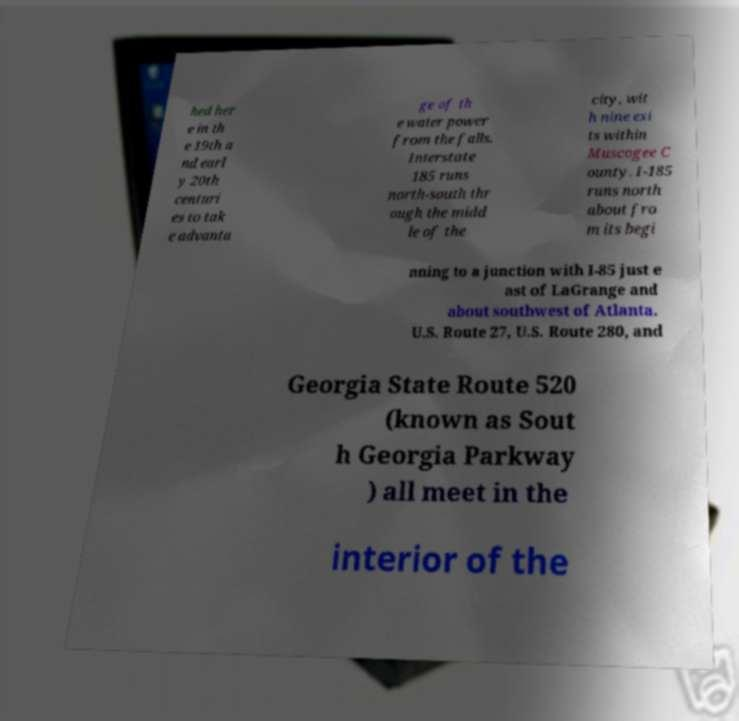Please identify and transcribe the text found in this image. hed her e in th e 19th a nd earl y 20th centuri es to tak e advanta ge of th e water power from the falls. Interstate 185 runs north-south thr ough the midd le of the city, wit h nine exi ts within Muscogee C ounty. I-185 runs north about fro m its begi nning to a junction with I-85 just e ast of LaGrange and about southwest of Atlanta. U.S. Route 27, U.S. Route 280, and Georgia State Route 520 (known as Sout h Georgia Parkway ) all meet in the interior of the 